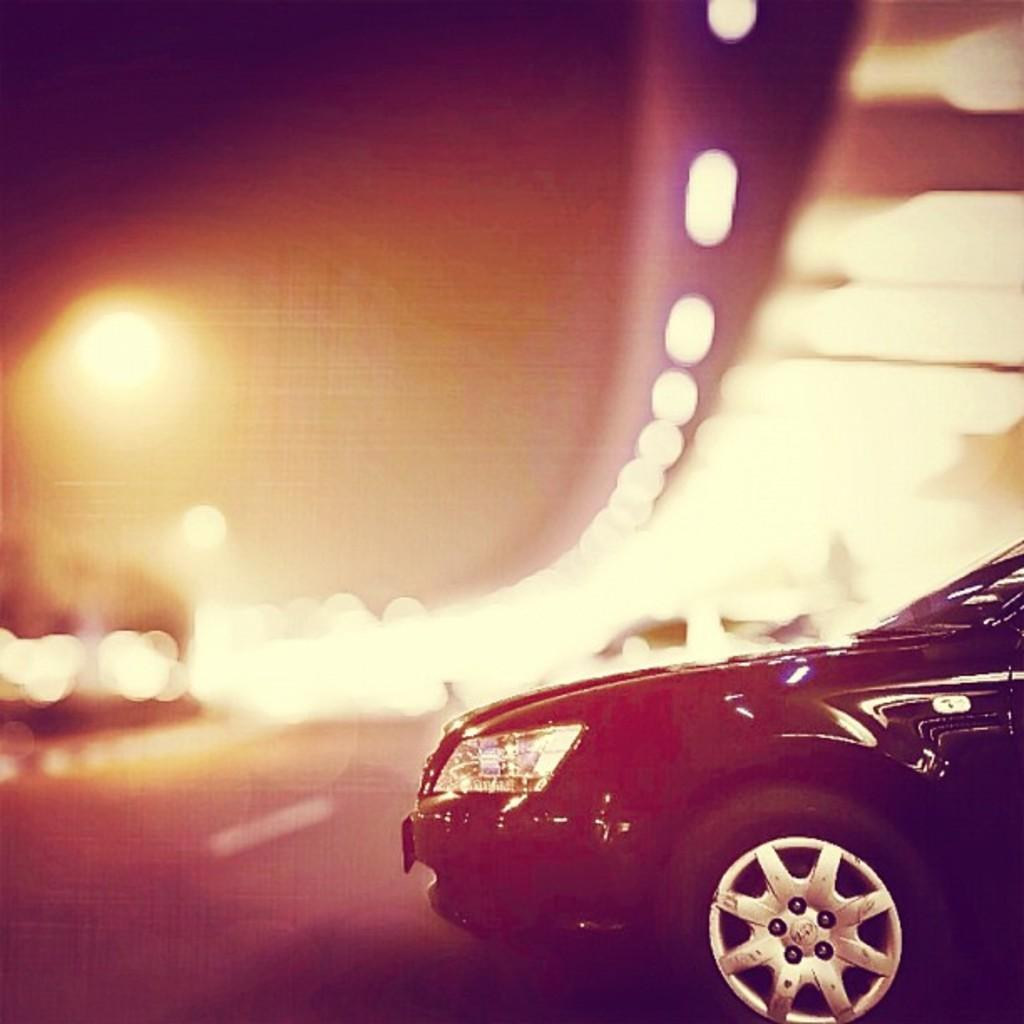What type of vehicle is in the image? There is a black car in the image. What is located at the bottom of the image? There is a road at the bottom of the image. What can be seen in the background of the image? There are lights visible in the background of the image. What type of advertisement is displayed on the side of the car in the image? There is no advertisement displayed on the side of the car in the image; it is a plain black car. 